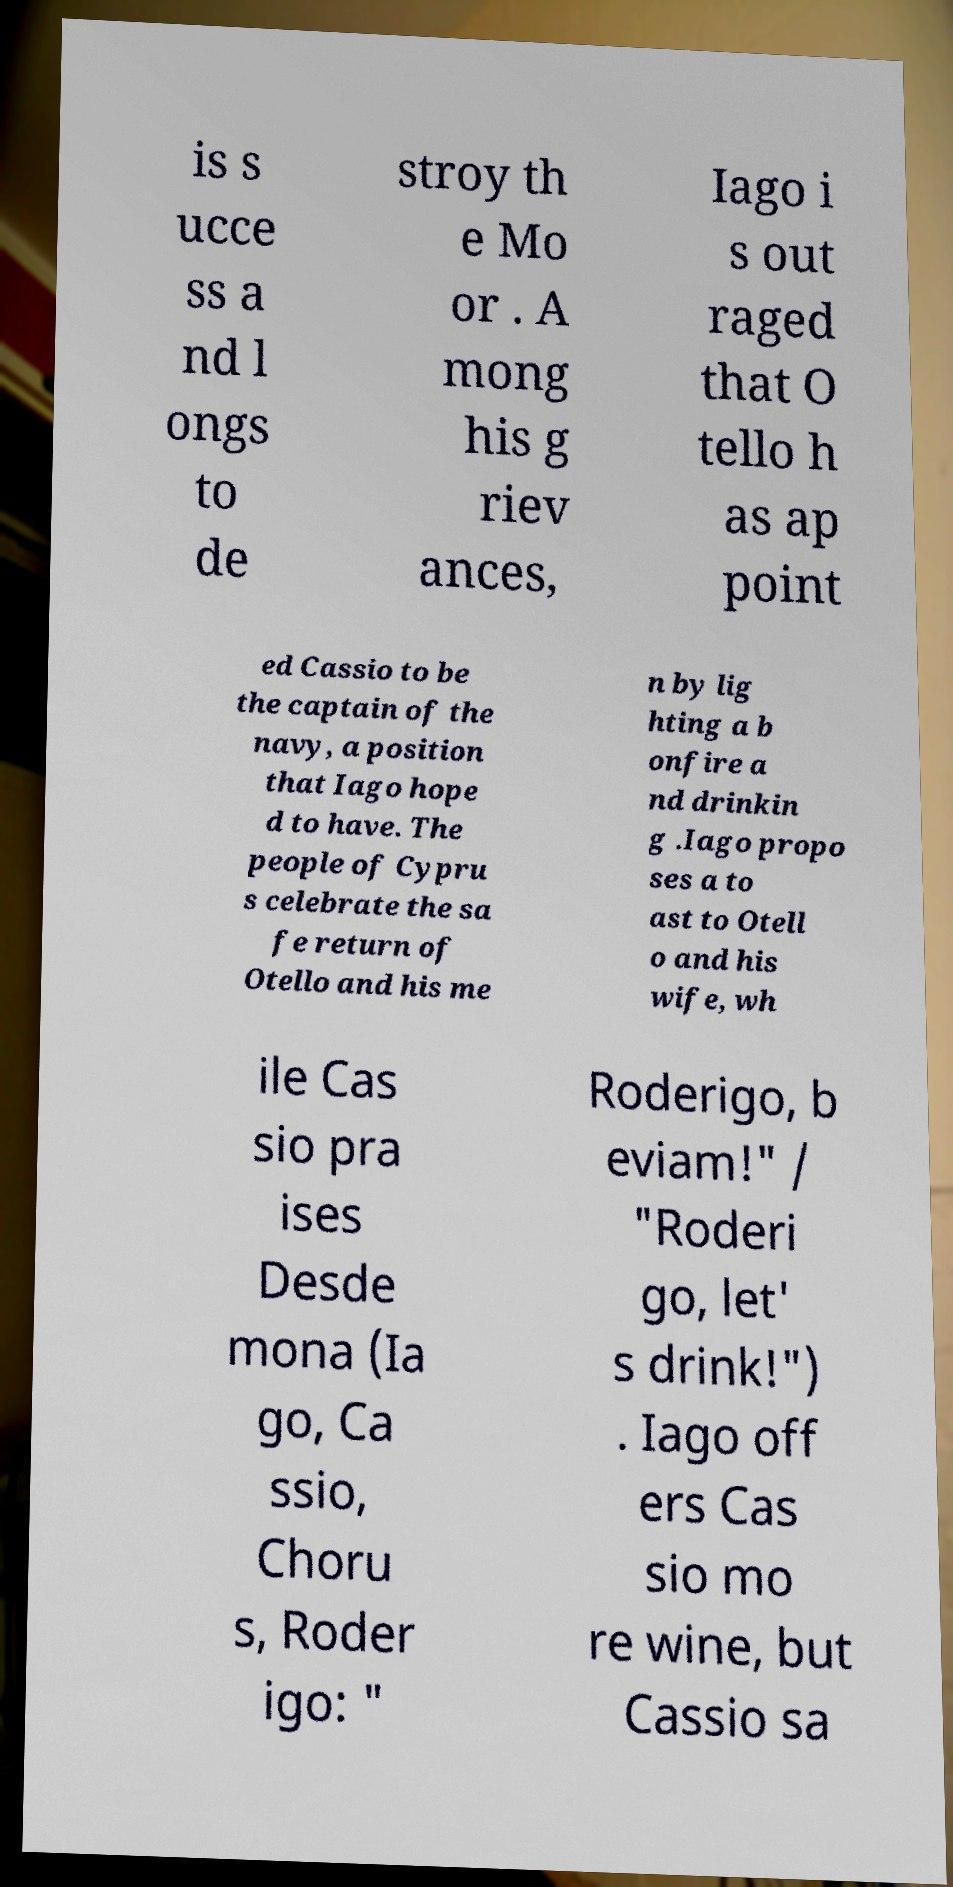Could you assist in decoding the text presented in this image and type it out clearly? is s ucce ss a nd l ongs to de stroy th e Mo or . A mong his g riev ances, Iago i s out raged that O tello h as ap point ed Cassio to be the captain of the navy, a position that Iago hope d to have. The people of Cypru s celebrate the sa fe return of Otello and his me n by lig hting a b onfire a nd drinkin g .Iago propo ses a to ast to Otell o and his wife, wh ile Cas sio pra ises Desde mona (Ia go, Ca ssio, Choru s, Roder igo: " Roderigo, b eviam!" / "Roderi go, let' s drink!") . Iago off ers Cas sio mo re wine, but Cassio sa 